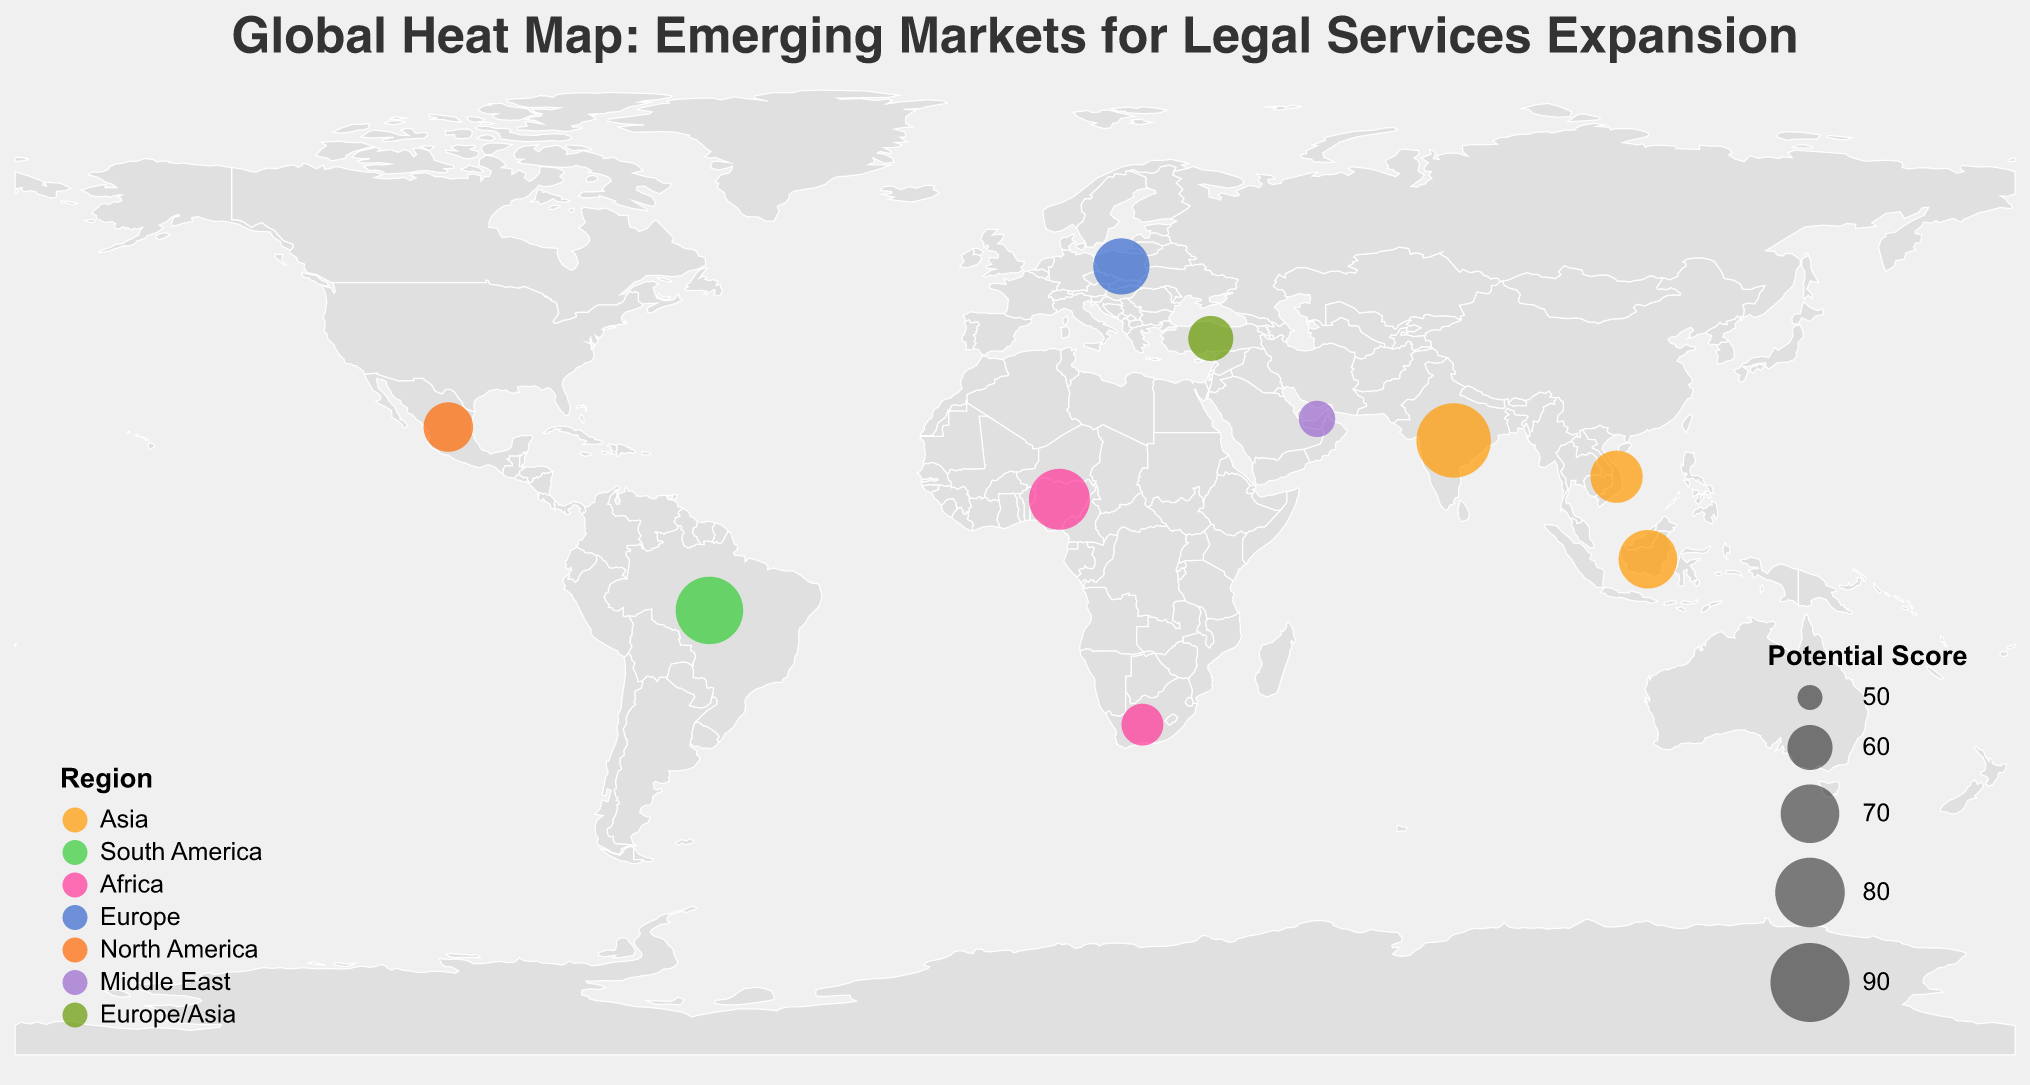Which country has the highest potential score? The highest potential score is depicted by the largest circle, and the country associated with this circle is India with a potential score of 85.
Answer: India Which region has the most countries displayed in the plot? By counting the number of countries associated with each region in the legend, Asia has the most countries displayed: India, Indonesia, and Vietnam.
Answer: Asia What is the key legal service area for the country with the lowest potential score? According to the plot, the United Arab Emirates has the lowest potential score of 55, and its key legal service area is Real Estate and Construction.
Answer: Real Estate and Construction What is the average potential score for European countries? The European countries listed are Poland and Turkey with potential scores of 68 and 60 respectively. The average is calculated as (68 + 60) / 2 = 64.
Answer: 64 Which country represents the Middle East region, and what is its potential score? The legend associates colors with regions, and the Middle East region’s color corresponds to the circle representing the United Arab Emirates with a potential score of 55.
Answer: United Arab Emirates, 55 Is there a country in North America on the plot, and if so, which one? The plot shows a country from North America, which is Mexico with a potential score of 63.
Answer: Mexico What are the key legal service areas in Asia according to the plot? The plot shows three countries in Asia: India (Corporate Law and M&A), Indonesia (Fintech and Digital Economy), and Vietnam (International Trade).
Answer: Corporate Law and M&A, Fintech and Digital Economy, International Trade Compare the potential scores of Nigeria and South Africa. Which one is higher? By looking at their corresponding circles and scores on the plot, Nigeria has a potential score of 72 while South Africa has a score of 58. Therefore, Nigeria has the higher potential score.
Answer: Nigeria Calculate the range of potential scores depicted in the plot. The range is determined by subtracting the lowest potential score (55, United Arab Emirates) from the highest potential score (85, India). So, the range is 85 - 55 = 30.
Answer: 30 How many countries in the plot have a potential score greater than 70? By examining the potential scores, four countries have a score greater than 70: India (85), Brazil (78), Nigeria (72), and Indonesia (70).
Answer: 4 